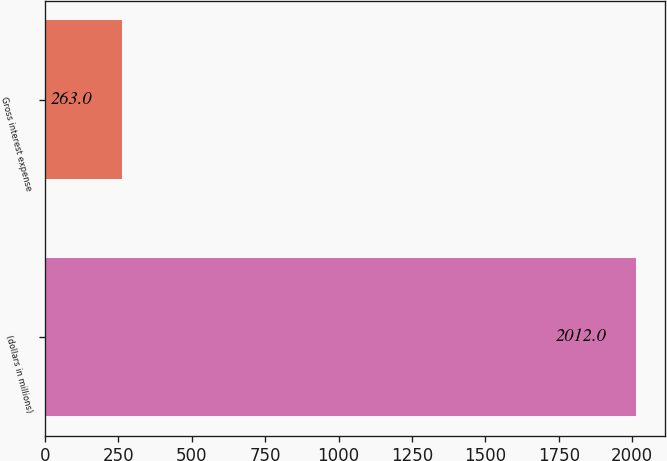<chart> <loc_0><loc_0><loc_500><loc_500><bar_chart><fcel>(dollars in millions)<fcel>Gross interest expense<nl><fcel>2012<fcel>263<nl></chart> 